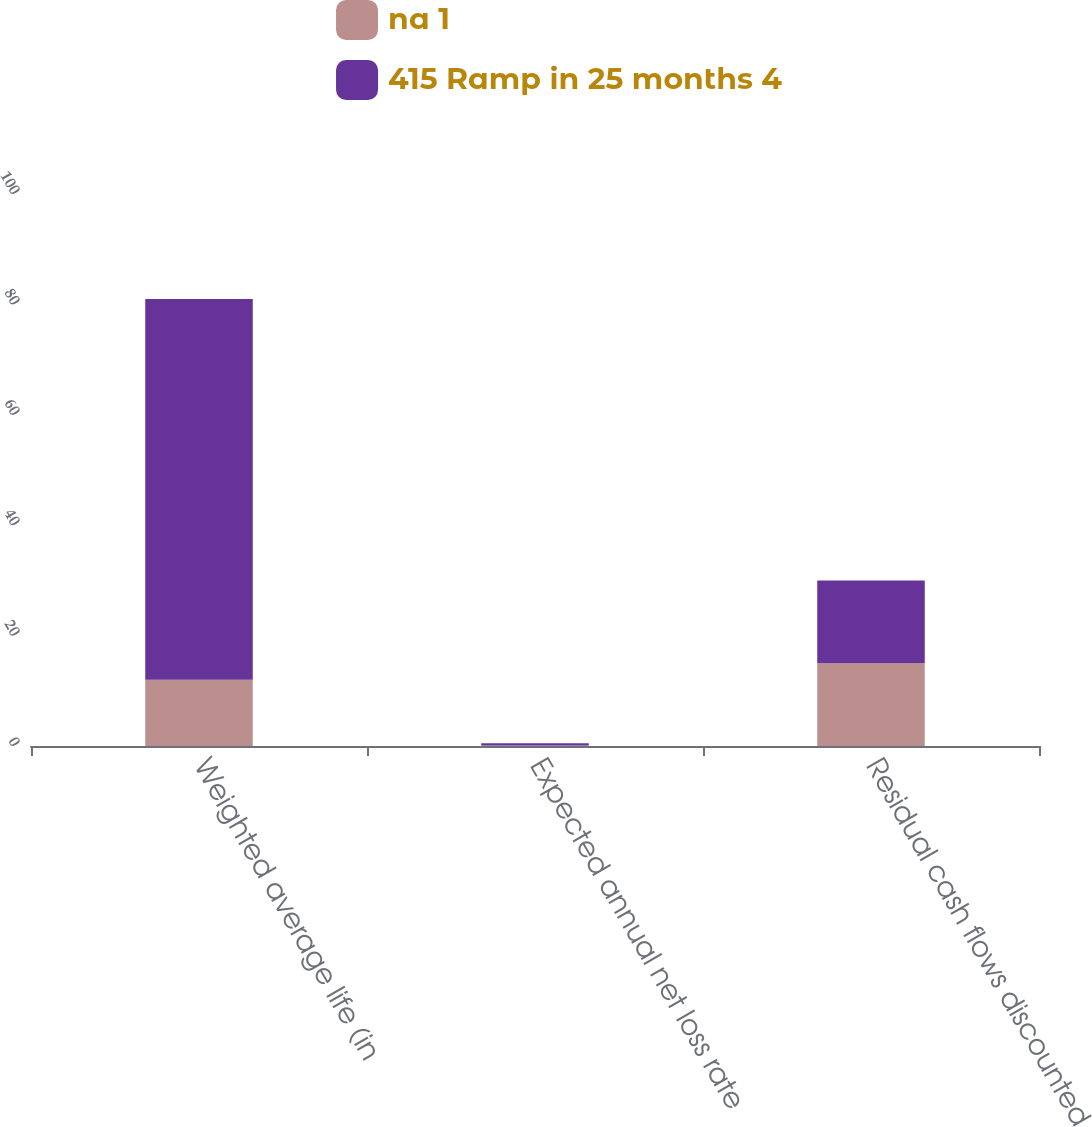Convert chart to OTSL. <chart><loc_0><loc_0><loc_500><loc_500><stacked_bar_chart><ecel><fcel>Weighted average life (in<fcel>Expected annual net loss rate<fcel>Residual cash flows discounted<nl><fcel>na 1<fcel>12<fcel>0.1<fcel>15<nl><fcel>415 Ramp in 25 months 4<fcel>69<fcel>0.4<fcel>15<nl></chart> 